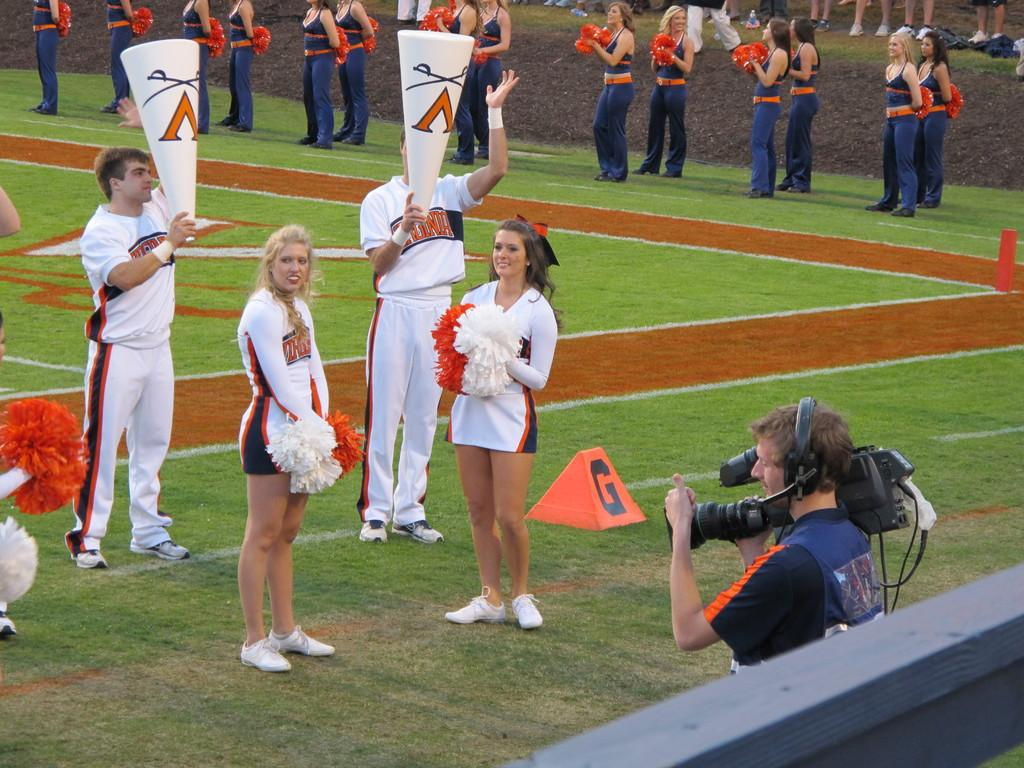<image>
Share a concise interpretation of the image provided. An orange marker with the black letter G sits behind a cheerleader on the sidelines. 